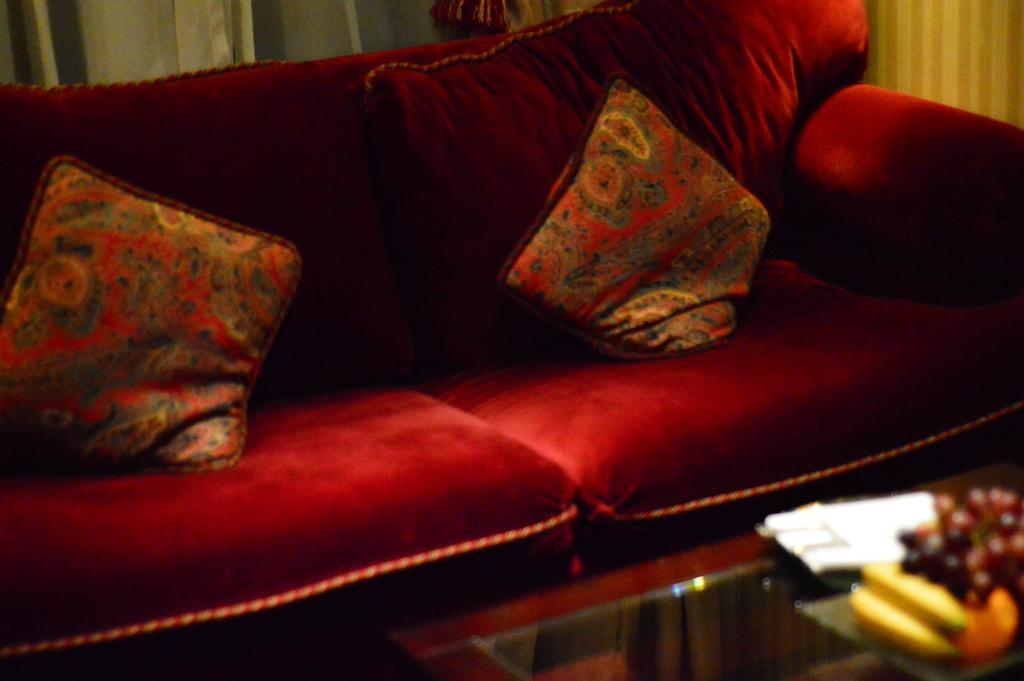What type of furniture is in the image? There is a red couch in the image. How many cushions are on the couch? The couch has two cushions on it. What is located near the couch in the image? There is a table in the image. What can be seen on the table? The table has fruits on it. What color is the object on the table? There is a white color object on the table. What type of hook is hanging from the ceiling in the image? There is no hook hanging from the ceiling in the image. 